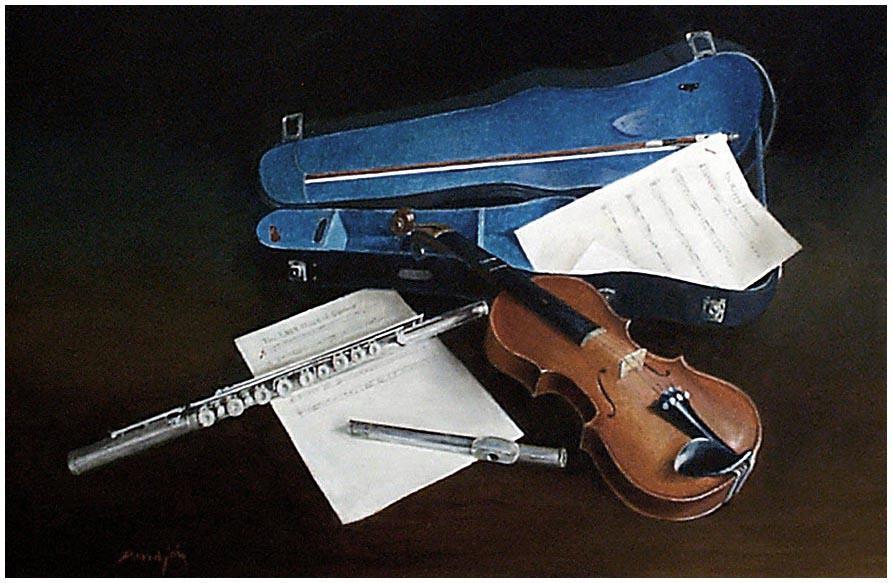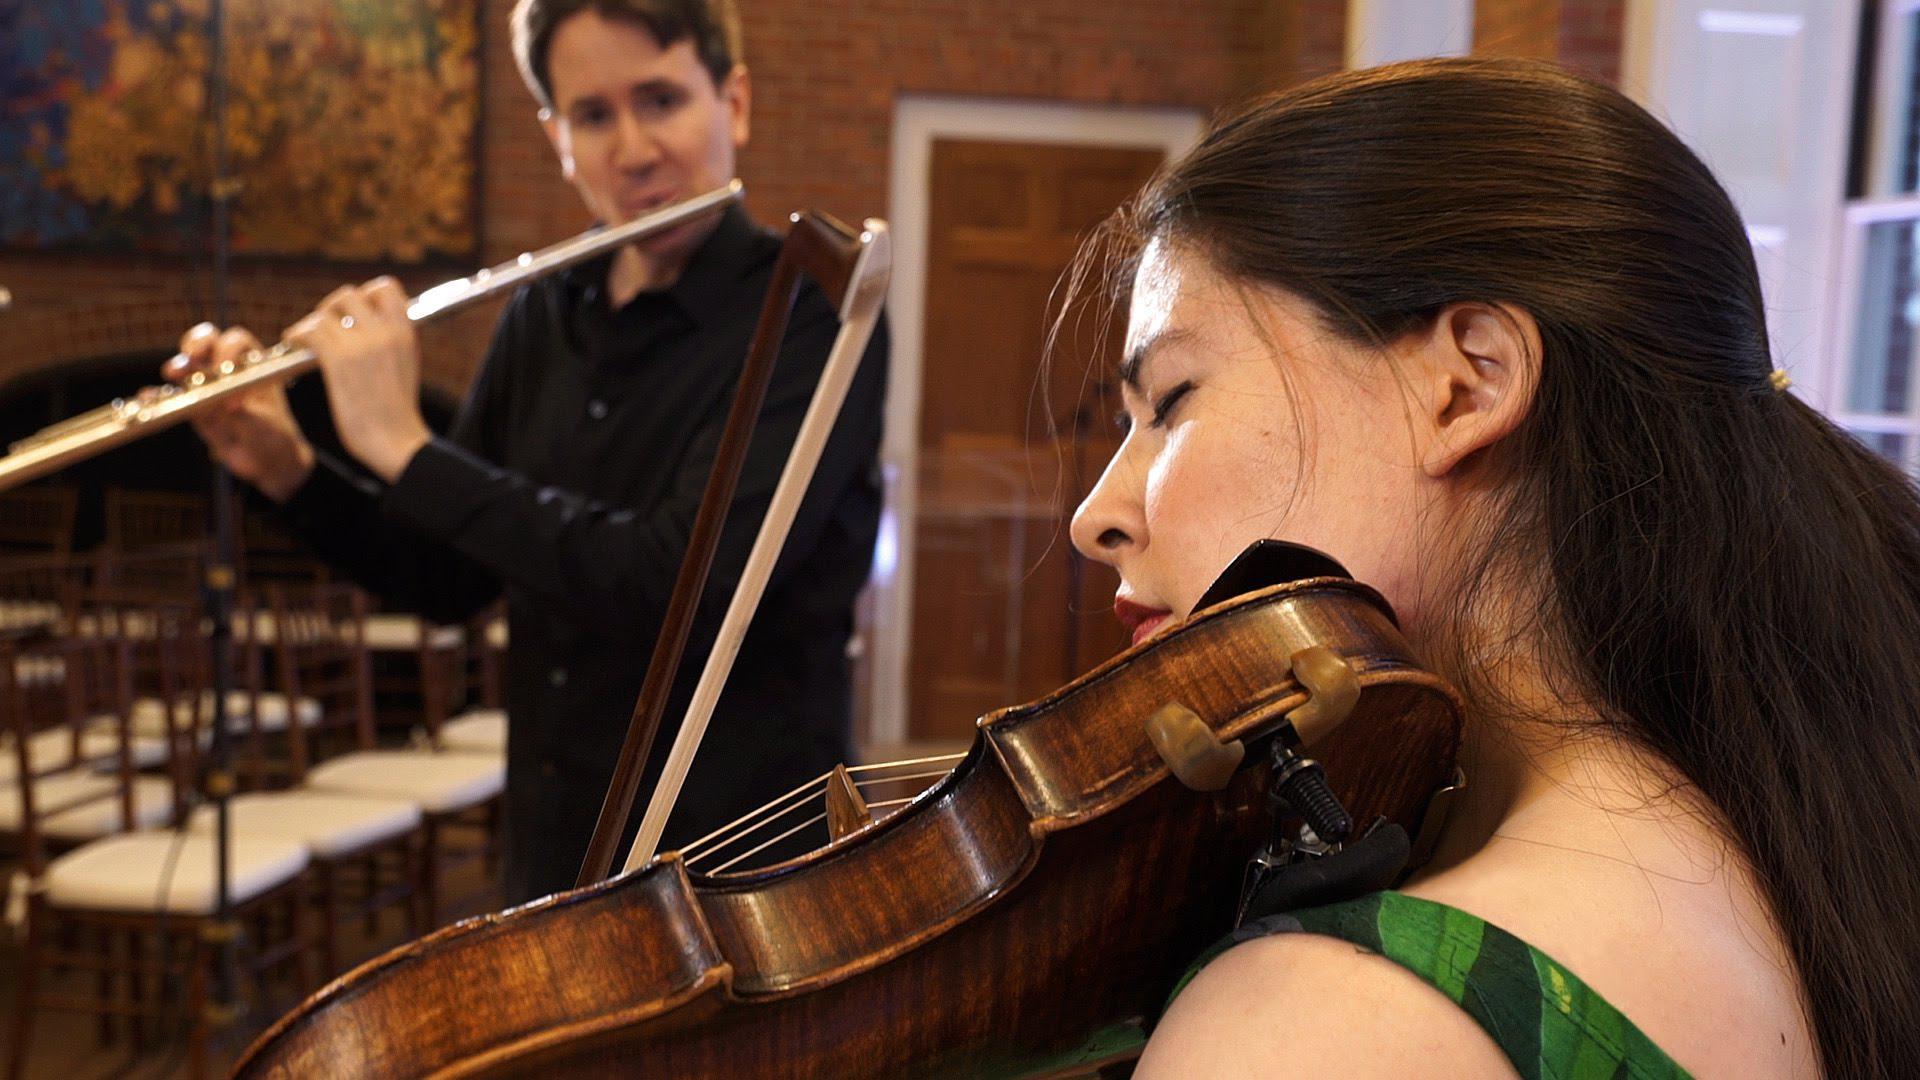The first image is the image on the left, the second image is the image on the right. Considering the images on both sides, is "A violin bow is touching violin strings and a flute." valid? Answer yes or no. No. The first image is the image on the left, the second image is the image on the right. Considering the images on both sides, is "An image features items displayed overlapping on a flat surface, including a violin, sheet music, and a straight wind instrument in pieces." valid? Answer yes or no. Yes. 